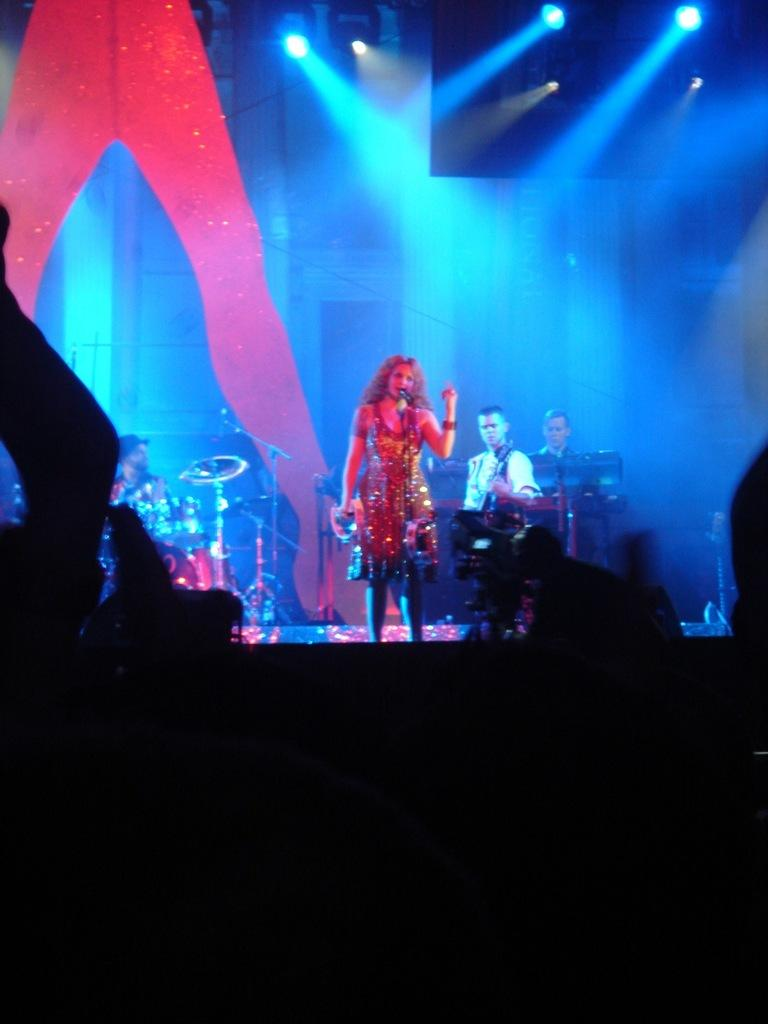Who or what is present in the image? There are people in the image. What are the people doing in the image? They are playing musical instruments in the image. What tools are used for amplifying sound in the image? There are microphones visible in the image. What can be seen providing illumination in the image? There are lights visible in the image. What type of toy can be seen being tested in the image? There is no toy or testing activity present in the image. What kind of cable is visible connecting the instruments in the image? There is no cable connecting the instruments visible in the image. 